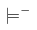<formula> <loc_0><loc_0><loc_500><loc_500>\models ^ { - }</formula> 